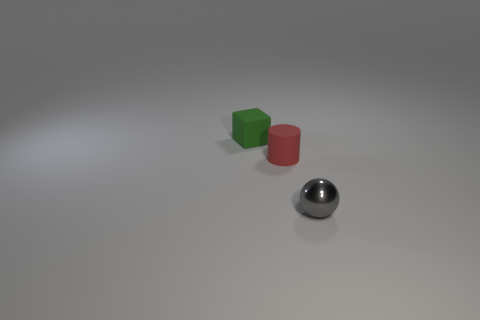Add 2 tiny matte cylinders. How many objects exist? 5 Subtract all cylinders. How many objects are left? 2 Add 2 gray spheres. How many gray spheres are left? 3 Add 3 gray metal cubes. How many gray metal cubes exist? 3 Subtract 0 purple spheres. How many objects are left? 3 Subtract all big red shiny cubes. Subtract all tiny balls. How many objects are left? 2 